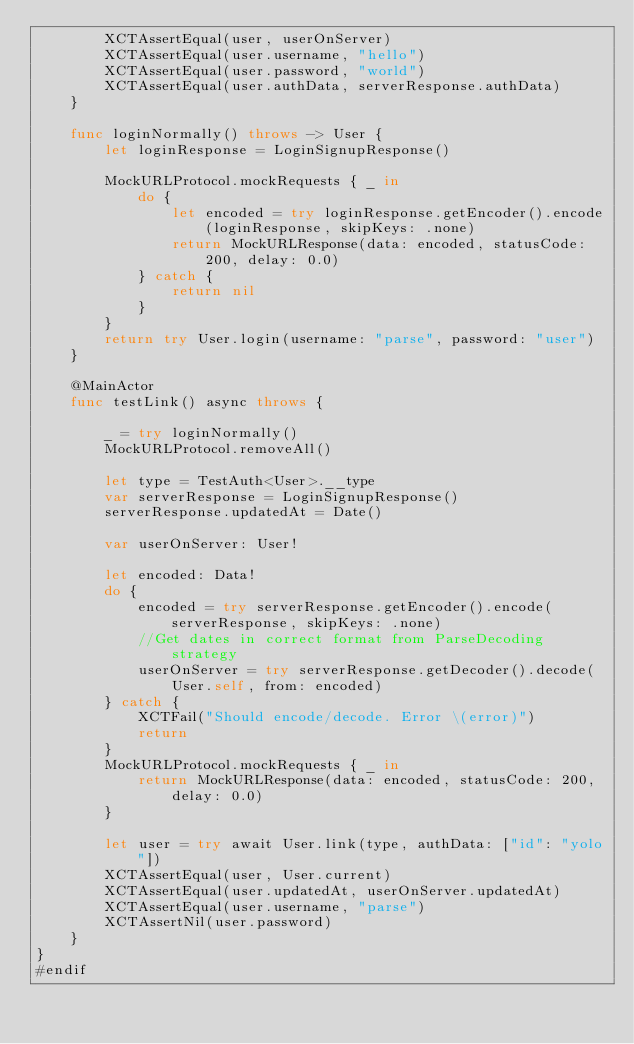<code> <loc_0><loc_0><loc_500><loc_500><_Swift_>        XCTAssertEqual(user, userOnServer)
        XCTAssertEqual(user.username, "hello")
        XCTAssertEqual(user.password, "world")
        XCTAssertEqual(user.authData, serverResponse.authData)
    }

    func loginNormally() throws -> User {
        let loginResponse = LoginSignupResponse()

        MockURLProtocol.mockRequests { _ in
            do {
                let encoded = try loginResponse.getEncoder().encode(loginResponse, skipKeys: .none)
                return MockURLResponse(data: encoded, statusCode: 200, delay: 0.0)
            } catch {
                return nil
            }
        }
        return try User.login(username: "parse", password: "user")
    }

    @MainActor
    func testLink() async throws {

        _ = try loginNormally()
        MockURLProtocol.removeAll()

        let type = TestAuth<User>.__type
        var serverResponse = LoginSignupResponse()
        serverResponse.updatedAt = Date()

        var userOnServer: User!

        let encoded: Data!
        do {
            encoded = try serverResponse.getEncoder().encode(serverResponse, skipKeys: .none)
            //Get dates in correct format from ParseDecoding strategy
            userOnServer = try serverResponse.getDecoder().decode(User.self, from: encoded)
        } catch {
            XCTFail("Should encode/decode. Error \(error)")
            return
        }
        MockURLProtocol.mockRequests { _ in
            return MockURLResponse(data: encoded, statusCode: 200, delay: 0.0)
        }

        let user = try await User.link(type, authData: ["id": "yolo"])
        XCTAssertEqual(user, User.current)
        XCTAssertEqual(user.updatedAt, userOnServer.updatedAt)
        XCTAssertEqual(user.username, "parse")
        XCTAssertNil(user.password)
    }
}
#endif
</code> 